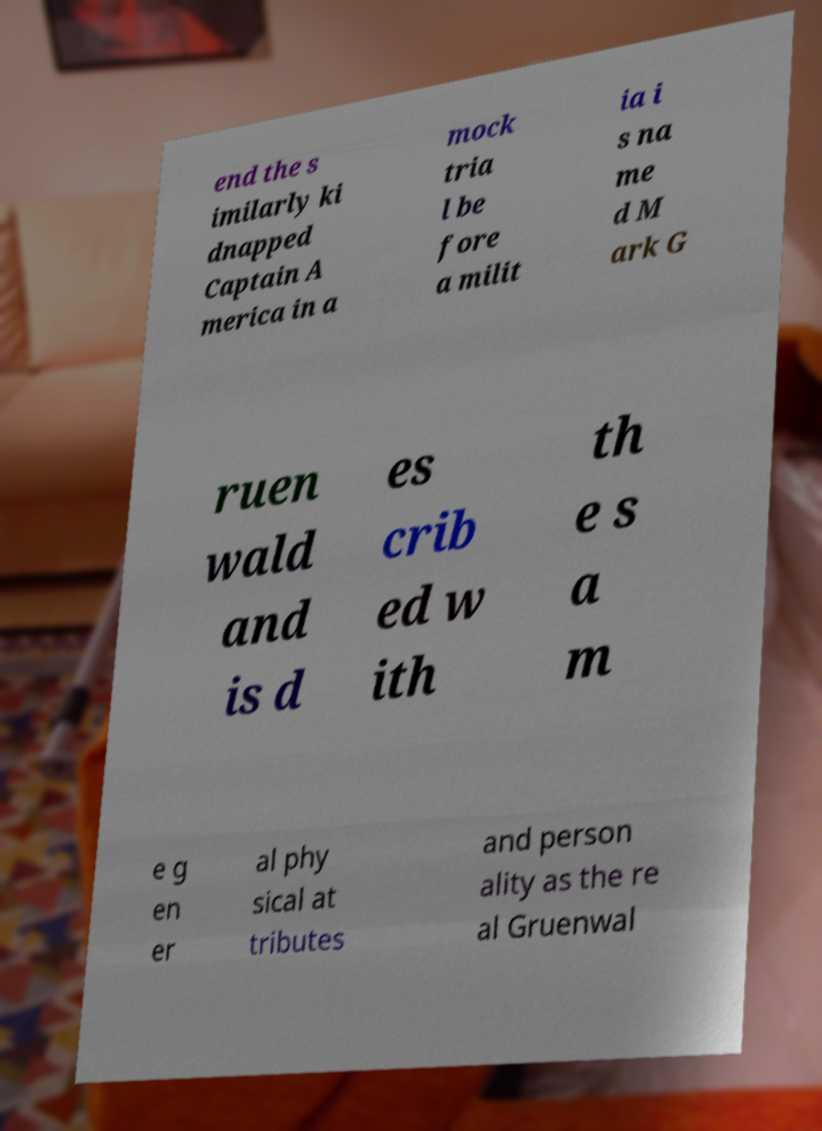I need the written content from this picture converted into text. Can you do that? end the s imilarly ki dnapped Captain A merica in a mock tria l be fore a milit ia i s na me d M ark G ruen wald and is d es crib ed w ith th e s a m e g en er al phy sical at tributes and person ality as the re al Gruenwal 